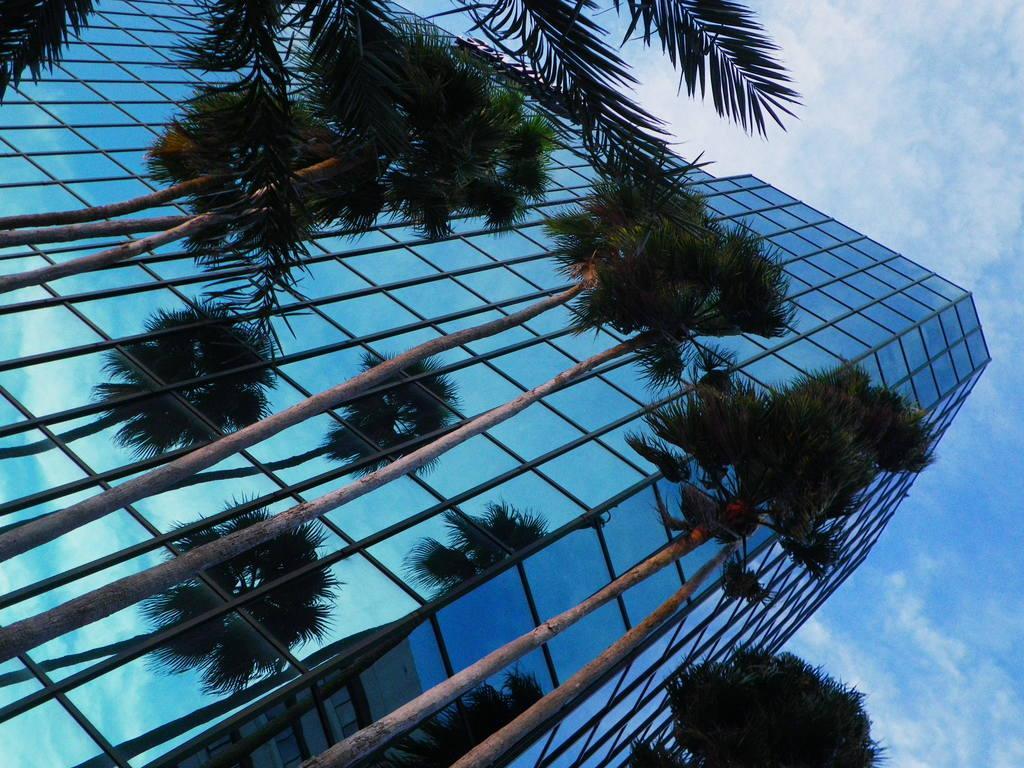Can you describe this image briefly? This picture is clicked outside. In the foreground we can see the trees and we can see the building and the reflection of trees and the reflection of another building on the glasses of the building. In the background we can see the sky and the clouds. 